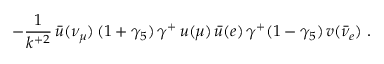<formula> <loc_0><loc_0><loc_500><loc_500>- \frac { 1 } { k ^ { + 2 } } \, { \bar { u } } ( \nu _ { \mu } ) \, ( 1 + \gamma _ { 5 } ) \, \gamma ^ { + } \, u ( \mu ) \, { \bar { u } } ( e ) \, \gamma ^ { + } ( 1 - \gamma _ { 5 } ) \, v ( { \bar { \nu } } _ { e } ) \ .</formula> 